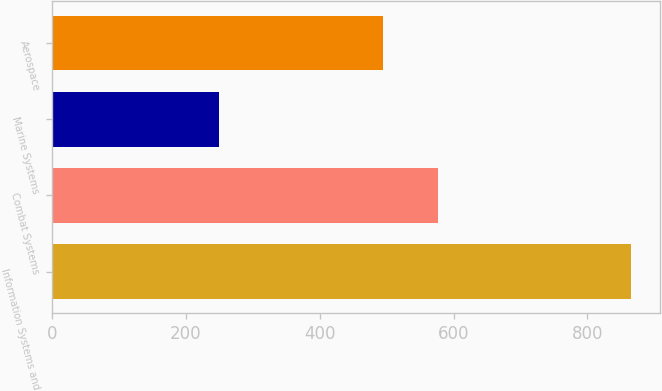<chart> <loc_0><loc_0><loc_500><loc_500><bar_chart><fcel>Information Systems and<fcel>Combat Systems<fcel>Marine Systems<fcel>Aerospace<nl><fcel>865<fcel>576<fcel>249<fcel>495<nl></chart> 